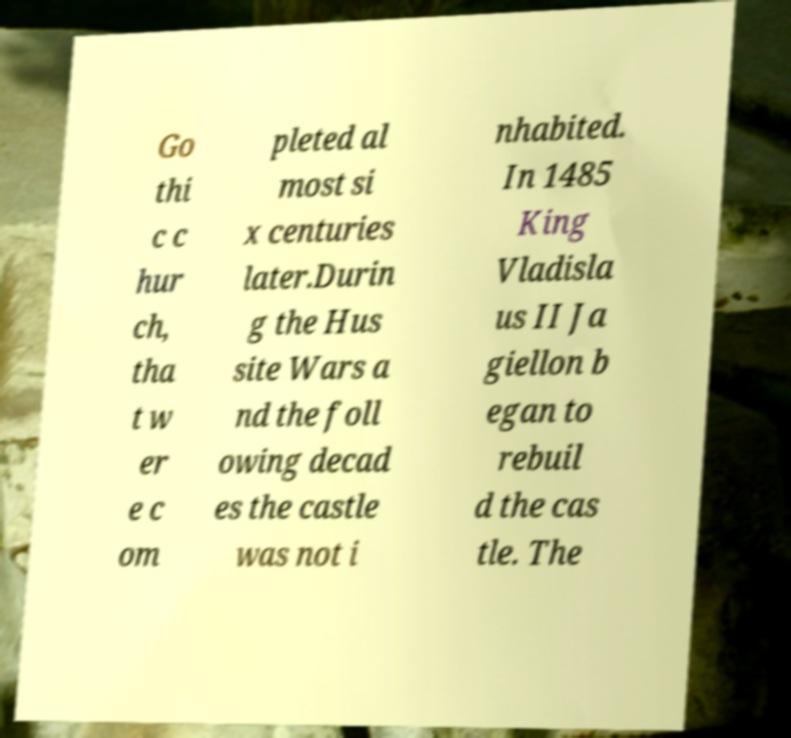What messages or text are displayed in this image? I need them in a readable, typed format. Go thi c c hur ch, tha t w er e c om pleted al most si x centuries later.Durin g the Hus site Wars a nd the foll owing decad es the castle was not i nhabited. In 1485 King Vladisla us II Ja giellon b egan to rebuil d the cas tle. The 